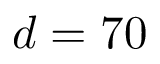<formula> <loc_0><loc_0><loc_500><loc_500>d = 7 0</formula> 